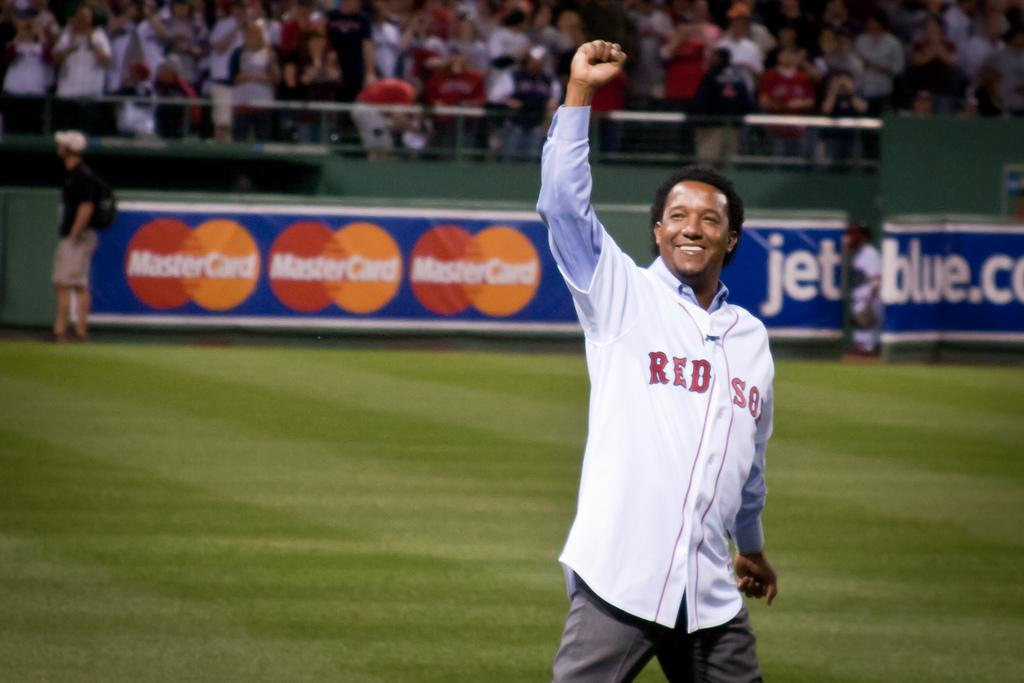<image>
Summarize the visual content of the image. a person holding up their fist and wearing a Red Sox jersey is on a baseball field 